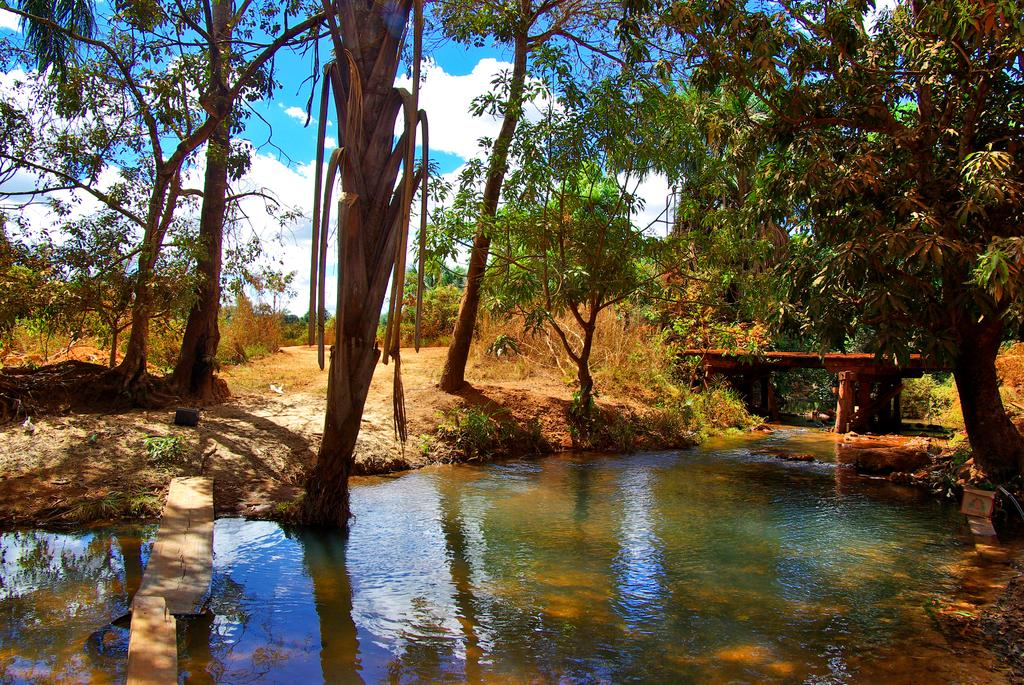What can be seen on the water's surface in the image? There are reflections of objects on the water in the image. What type of objects are made of wood in the image? There are wooden objects in the image. What structure can be seen crossing the water in the image? There is a bridge in the image. What type of vegetation is present in the image? There are trees in the image. What other objects can be seen in the image besides the wooden ones? There are other objects in the image. How would you describe the sky in the image? The sky is cloudy in the image. Where is the playground located in the image? There is no playground present in the image. What type of cord is used to hang the wooden objects in the image? There is no cord visible in the image, and the wooden objects are not hanging. 